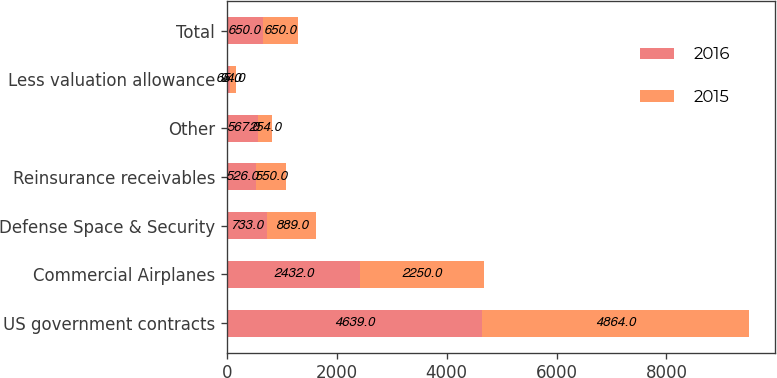<chart> <loc_0><loc_0><loc_500><loc_500><stacked_bar_chart><ecel><fcel>US government contracts<fcel>Commercial Airplanes<fcel>Defense Space & Security<fcel>Reinsurance receivables<fcel>Other<fcel>Less valuation allowance<fcel>Total<nl><fcel>2016<fcel>4639<fcel>2432<fcel>733<fcel>526<fcel>567<fcel>65<fcel>650<nl><fcel>2015<fcel>4864<fcel>2250<fcel>889<fcel>550<fcel>254<fcel>94<fcel>650<nl></chart> 